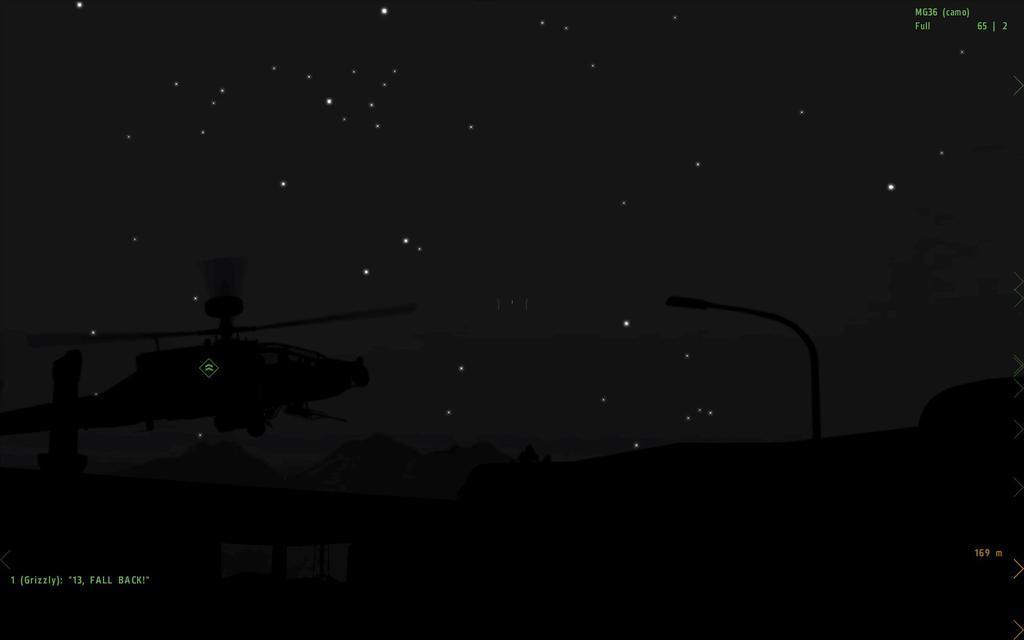How would you summarize this image in a sentence or two? In this image we can see a helicopter and group of mountains , light poles on the screen and some text on it. 